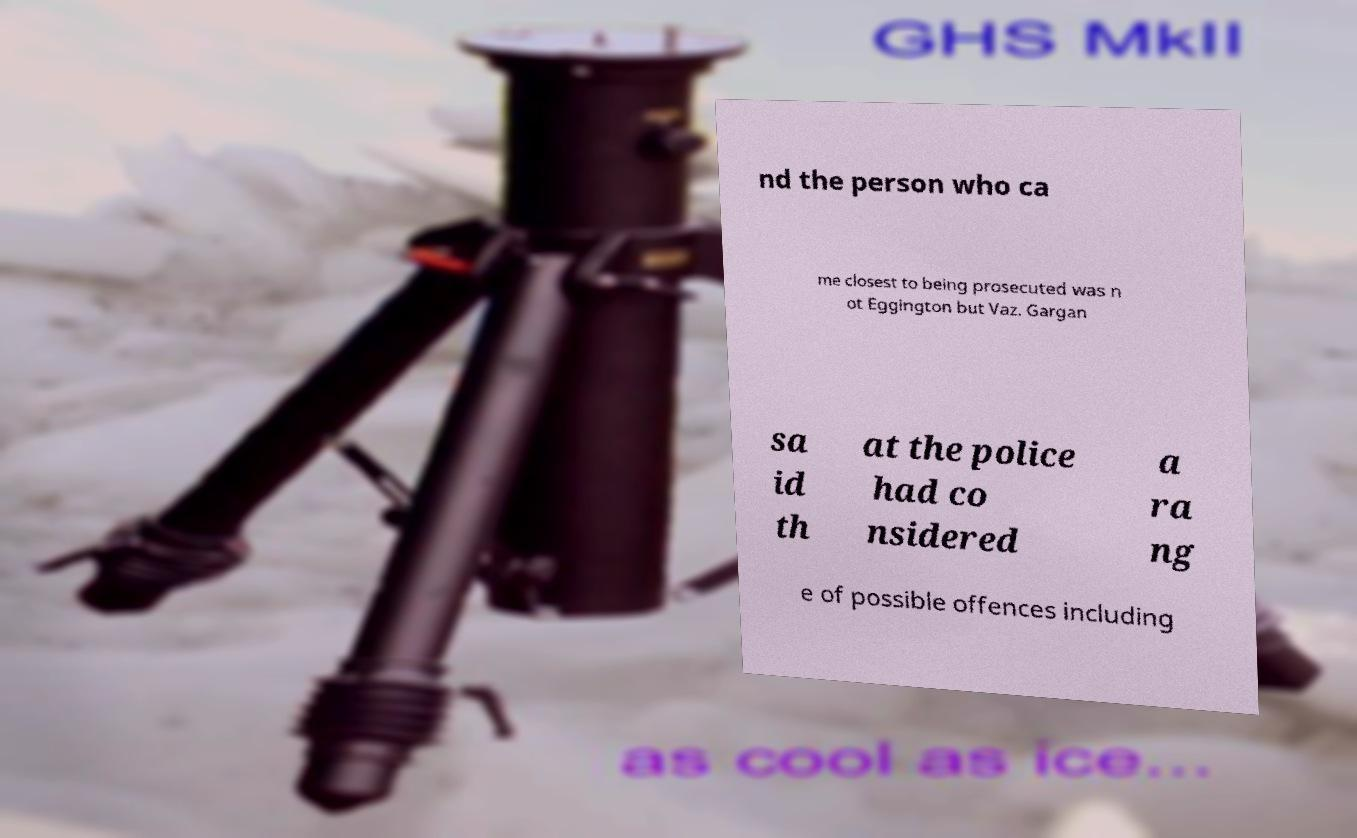Please read and relay the text visible in this image. What does it say? nd the person who ca me closest to being prosecuted was n ot Eggington but Vaz. Gargan sa id th at the police had co nsidered a ra ng e of possible offences including 